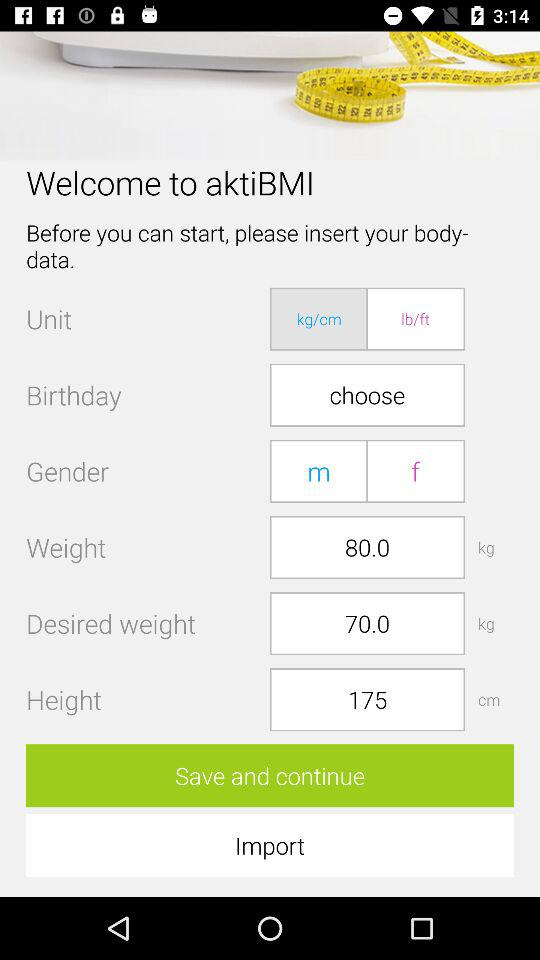What is the application name? The application name is "aktiBMI". 